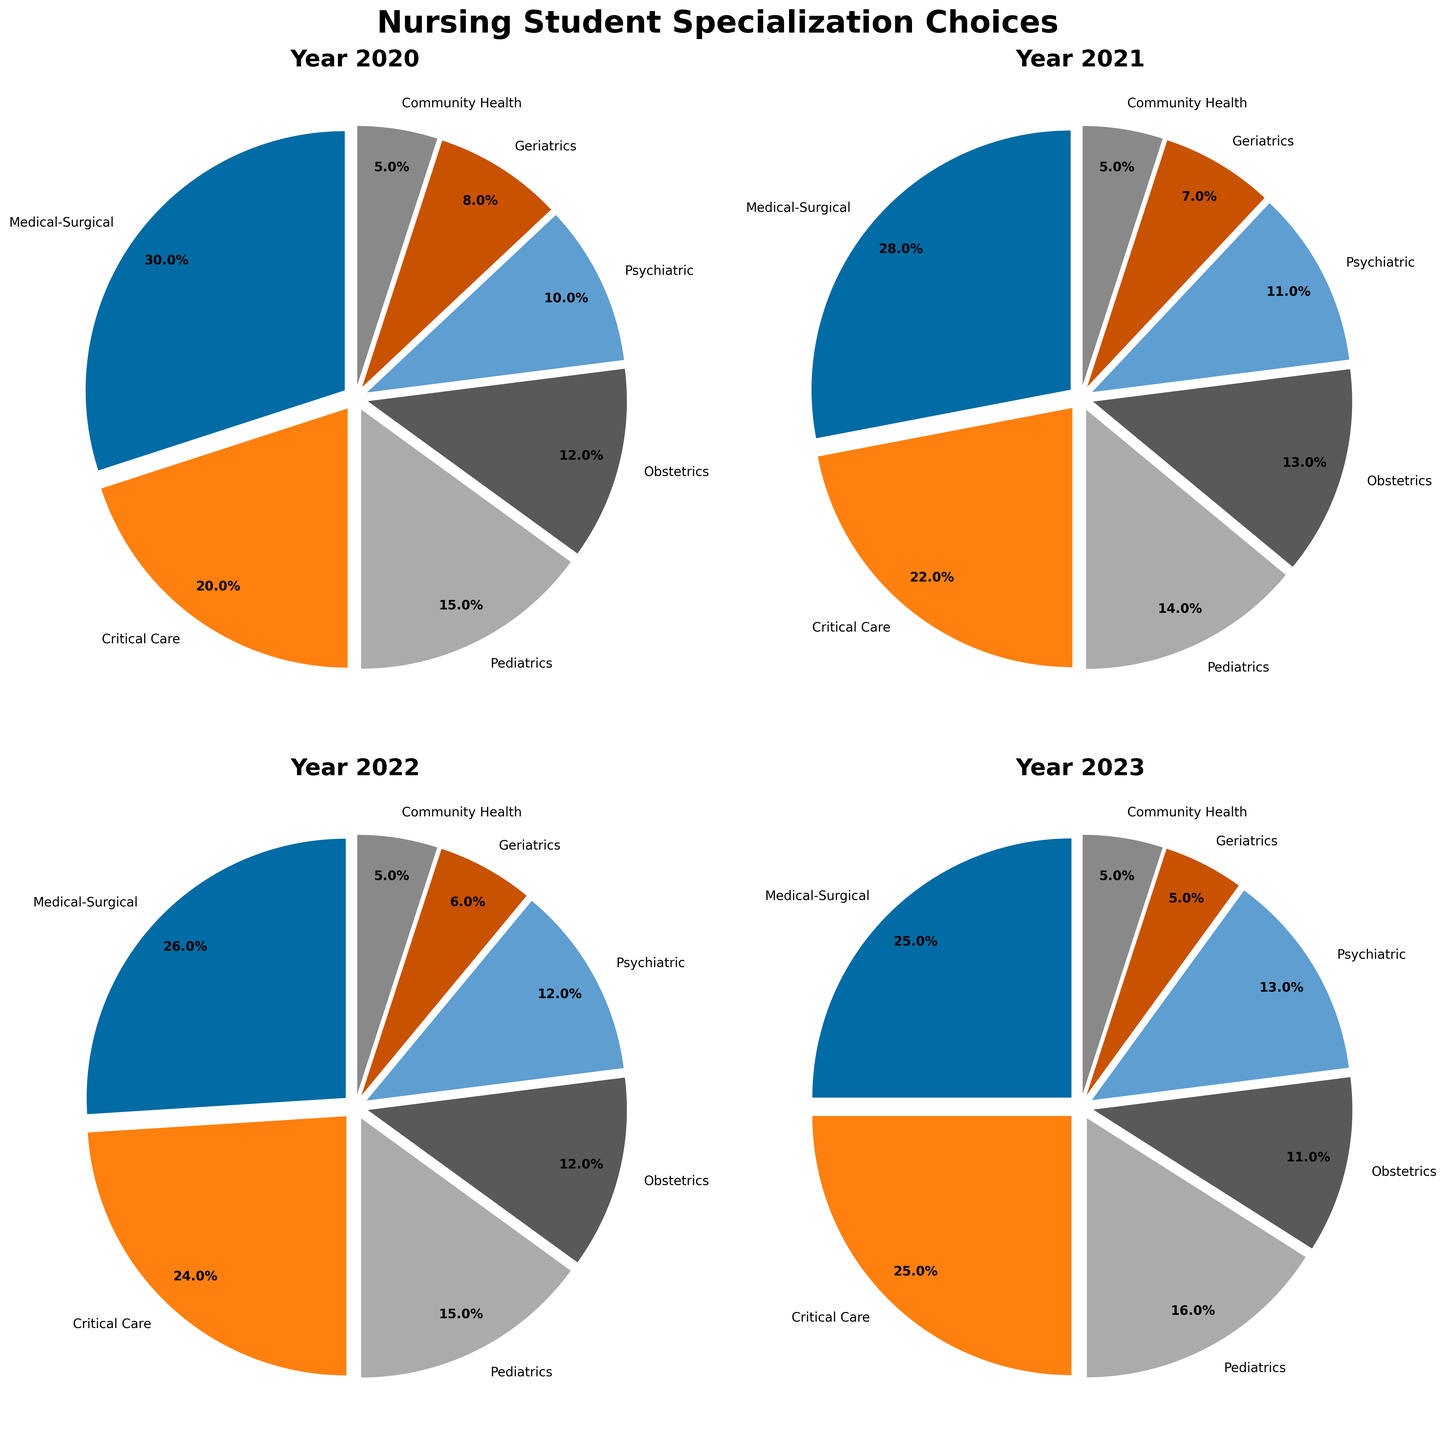Which specialization had the highest percentage in 2020? By looking at the 2020 pie chart, Medical-Surgical has the largest slice.
Answer: Medical-Surgical How did the percentage of Pediatrics specialization change from 2020 to 2023? By comparing the slices for Pediatrics in 2020 (15%) and 2023 (16%), the percentage increased by 1%.
Answer: Increased by 1% Which two specializations had equal percentages in 2023? The 2023 pie chart shows Community Health and Geriatrics each with a slice representing 5%.
Answer: Community Health, Geriatrics What is the sum of the percentages for Critical Care and Pediatrics in 2022? The 2022 pie chart shows Critical Care at 24% and Pediatrics at 15%. Adding them, 24% + 15% = 39%.
Answer: 39% How did the percentage of Medical-Surgical specialization change from 2020 to 2023? Medical-Surgical was 30% in 2020 and decreased to 25% in 2023. The change is 30% - 25% = 5%.
Answer: Decreased by 5% Which specialization showed an increasing trend every year from 2020 to 2023? By examining each year's pie chart, Critical Care increased from 20% in 2020 to 25% in 2023.
Answer: Critical Care In 2021, which specialization had the smallest percentage? The 2021 pie chart shows Community Health with the smallest slice at 5%.
Answer: Community Health Which year had the highest percentage for Psychiatric specialization? Psychiatric specialization had the highest percentage in 2023 with 13%, as shown in the 2023 pie chart.
Answer: 2023 What is the difference in percentage for Geriatrics specialization between 2020 and 2023? Geriatrics had 8% in 2020 and 5% in 2023. The difference is 8% - 5% = 3%.
Answer: 3% Which specialization was most stable in percentage from 2020 to 2023? Community Health remained constant at 5% each year, as evident from all the pie charts.
Answer: Community Health 